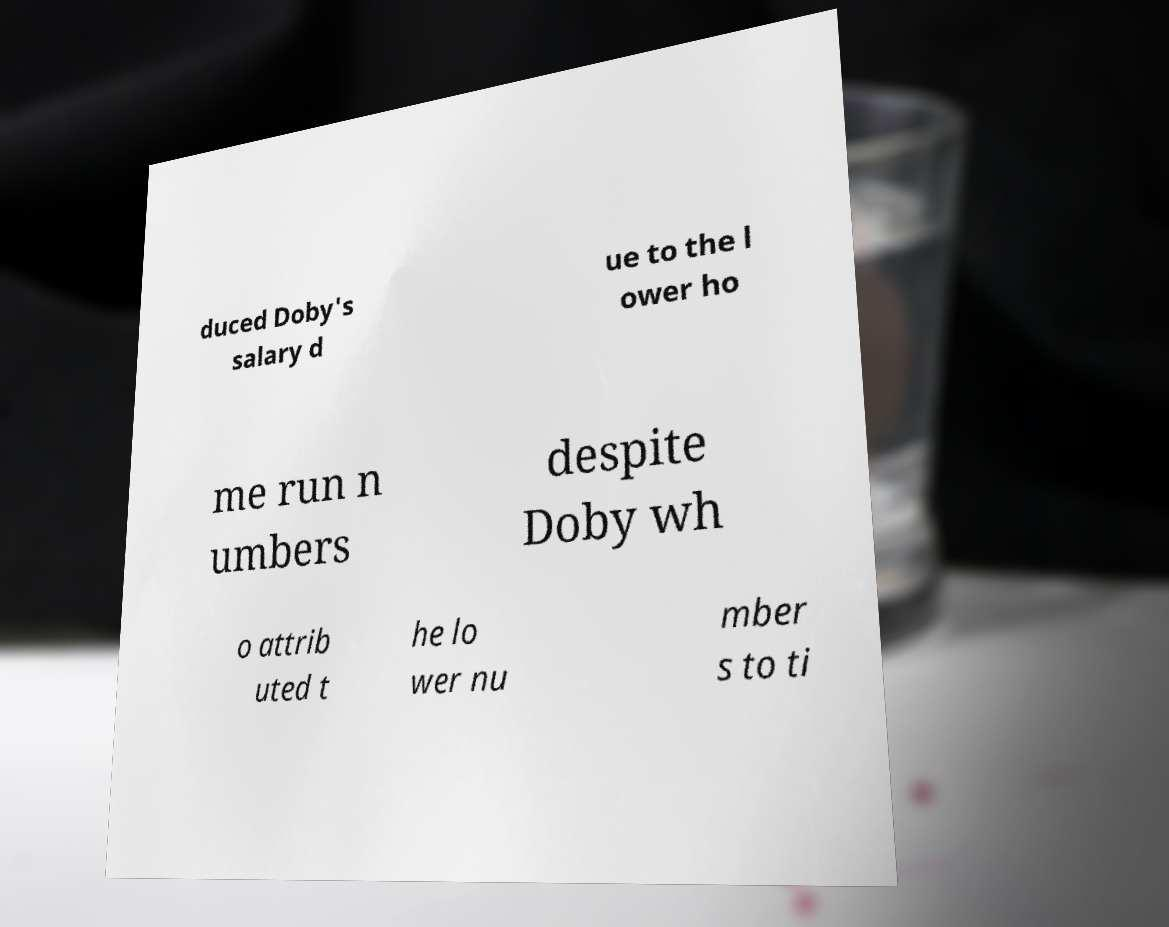Can you accurately transcribe the text from the provided image for me? duced Doby's salary d ue to the l ower ho me run n umbers despite Doby wh o attrib uted t he lo wer nu mber s to ti 